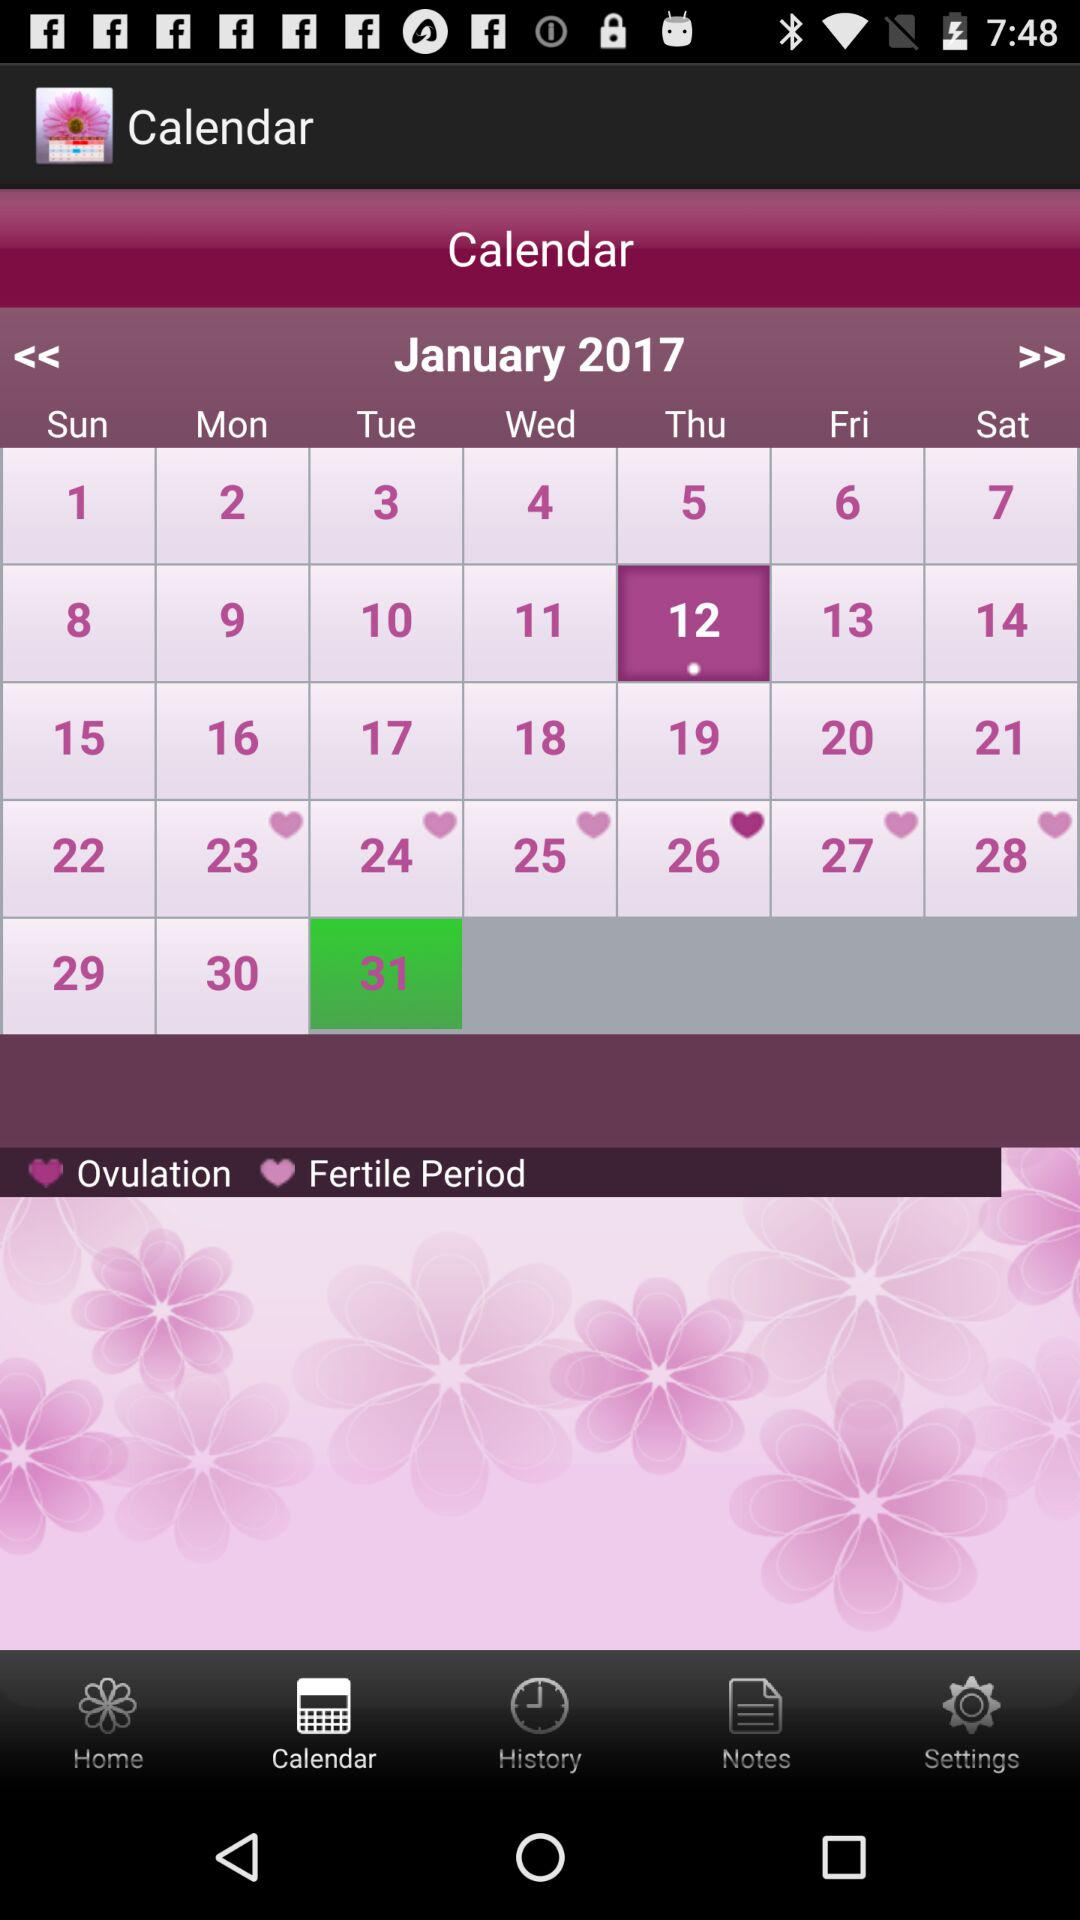Which date is selected? The selected date is Tuesday, January 31, 2017. 